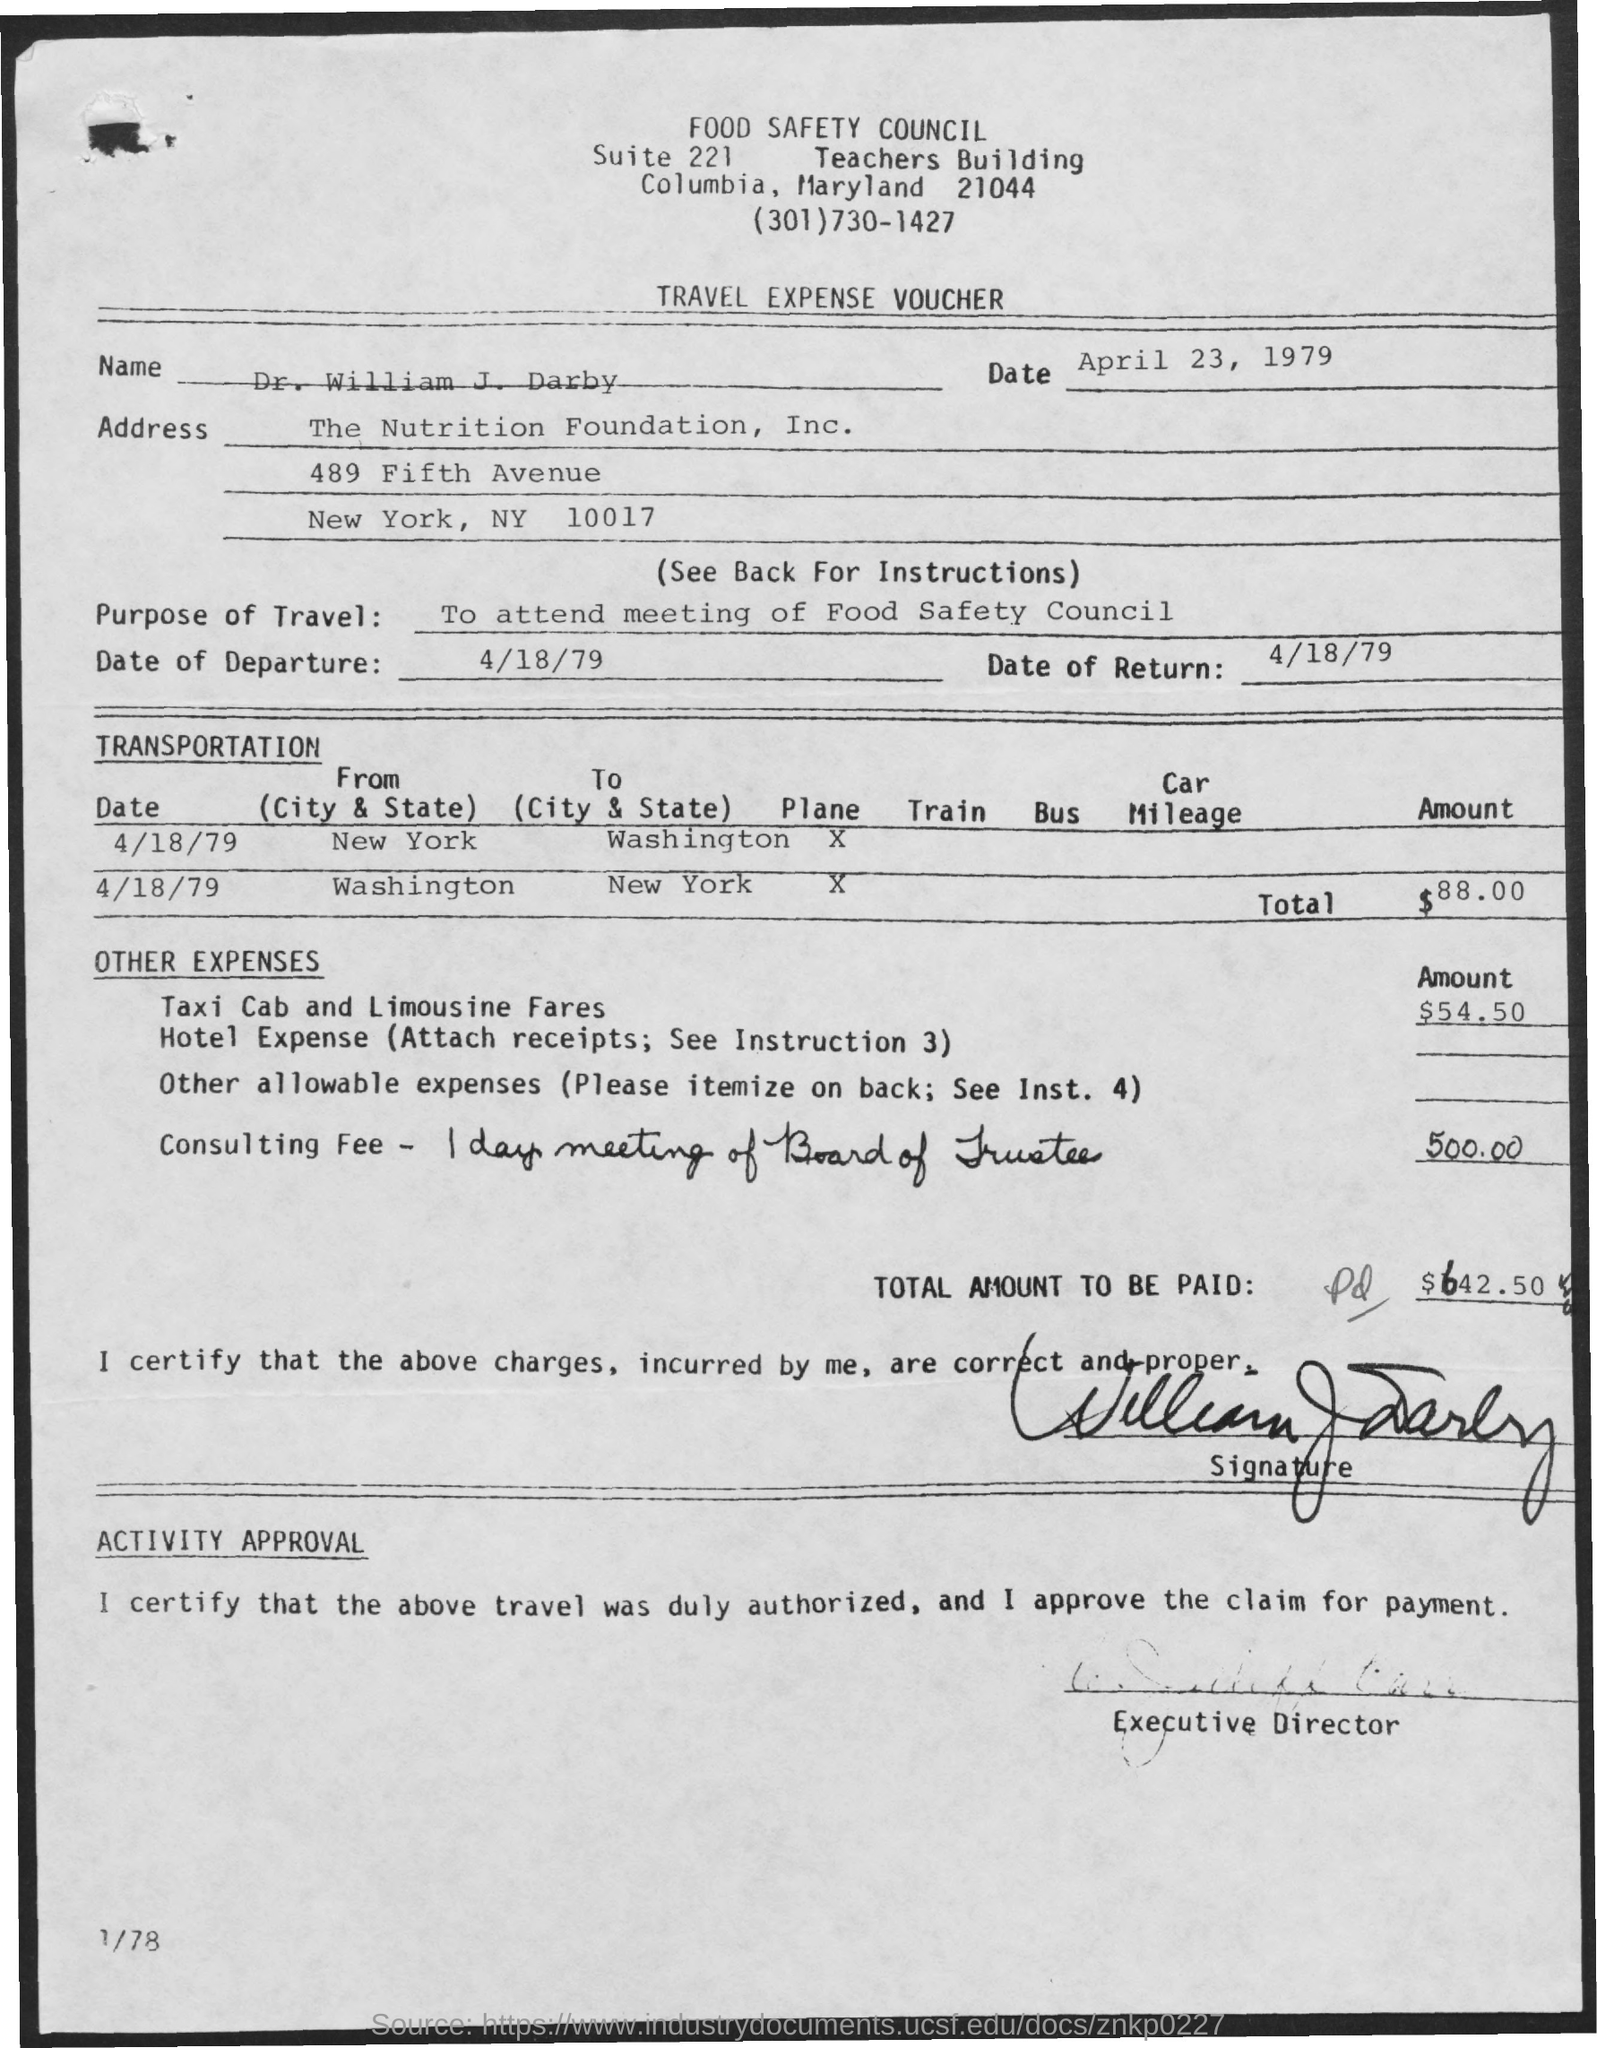What type of Voucher this ?
Provide a succinct answer. TRAVEL EXPENSE VOUCHER. What is the date mentioned in the top of the document ?
Make the answer very short. April 23, 1979. What is the date of Departure ?
Provide a succinct answer. 4/18/79. What is the Return Date ?
Provide a succinct answer. 4/18/79. What is written in the top of the document ?
Your answer should be compact. FOOD SAFETY COUNCIL. 